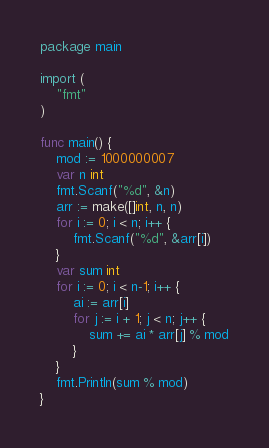<code> <loc_0><loc_0><loc_500><loc_500><_Go_>package main

import (
	"fmt"
)

func main() {
	mod := 1000000007
	var n int
	fmt.Scanf("%d", &n)
	arr := make([]int, n, n)
	for i := 0; i < n; i++ {
		fmt.Scanf("%d", &arr[i])
	}
	var sum int
	for i := 0; i < n-1; i++ {
		ai := arr[i]
		for j := i + 1; j < n; j++ {
			sum += ai * arr[j] % mod
		}
	}
	fmt.Println(sum % mod)
}
</code> 